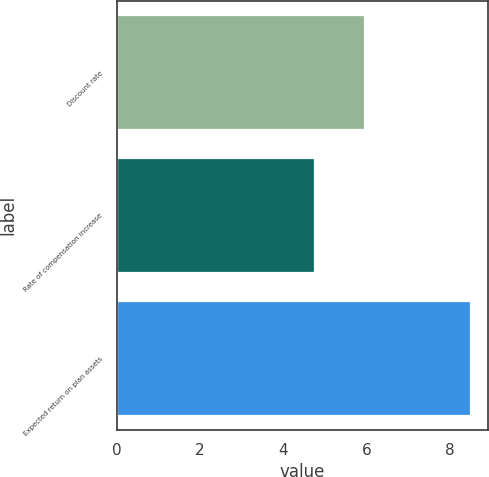Convert chart to OTSL. <chart><loc_0><loc_0><loc_500><loc_500><bar_chart><fcel>Discount rate<fcel>Rate of compensation increase<fcel>Expected return on plan assets<nl><fcel>5.94<fcel>4.75<fcel>8.5<nl></chart> 